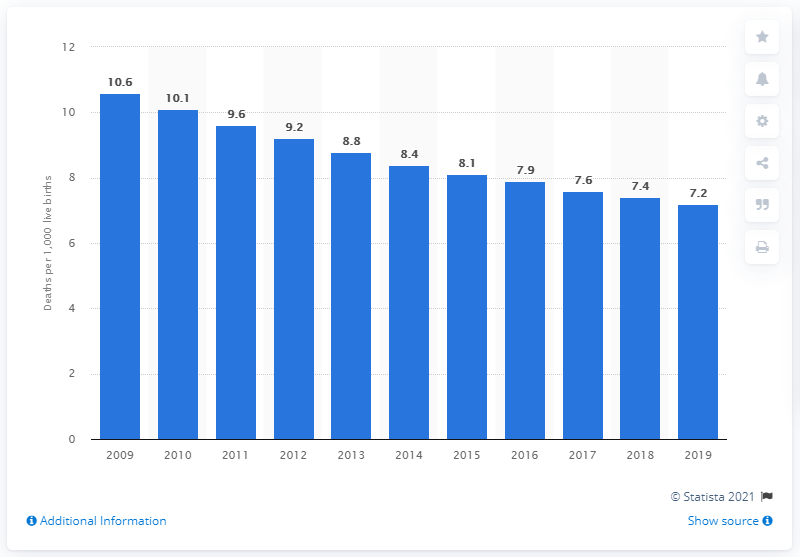Draw attention to some important aspects in this diagram. According to data from 2019, the infant mortality rate in Ukraine was 7.2 deaths per 1,000 live births. 